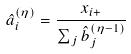Convert formula to latex. <formula><loc_0><loc_0><loc_500><loc_500>\hat { a } _ { i } ^ { ( \eta ) } = \frac { x _ { i + } } { \sum _ { j } \hat { b } _ { j } ^ { ( \eta - 1 ) } }</formula> 